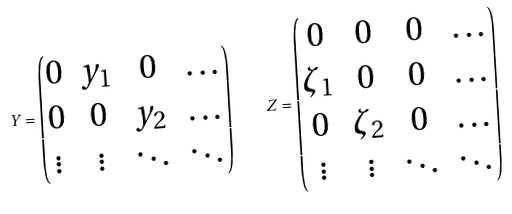Convert formula to latex. <formula><loc_0><loc_0><loc_500><loc_500>Y = \begin{pmatrix} 0 & y _ { 1 } & 0 & \dots \\ 0 & 0 & y _ { 2 } & \dots \\ \vdots & \vdots & \ddots & \ddots \end{pmatrix} \quad Z = \begin{pmatrix} 0 & 0 & 0 & \dots \\ \zeta _ { 1 } & 0 & 0 & \dots \\ 0 & \zeta _ { 2 } & 0 & \dots \\ \vdots & \vdots & \ddots & \ddots \end{pmatrix}</formula> 